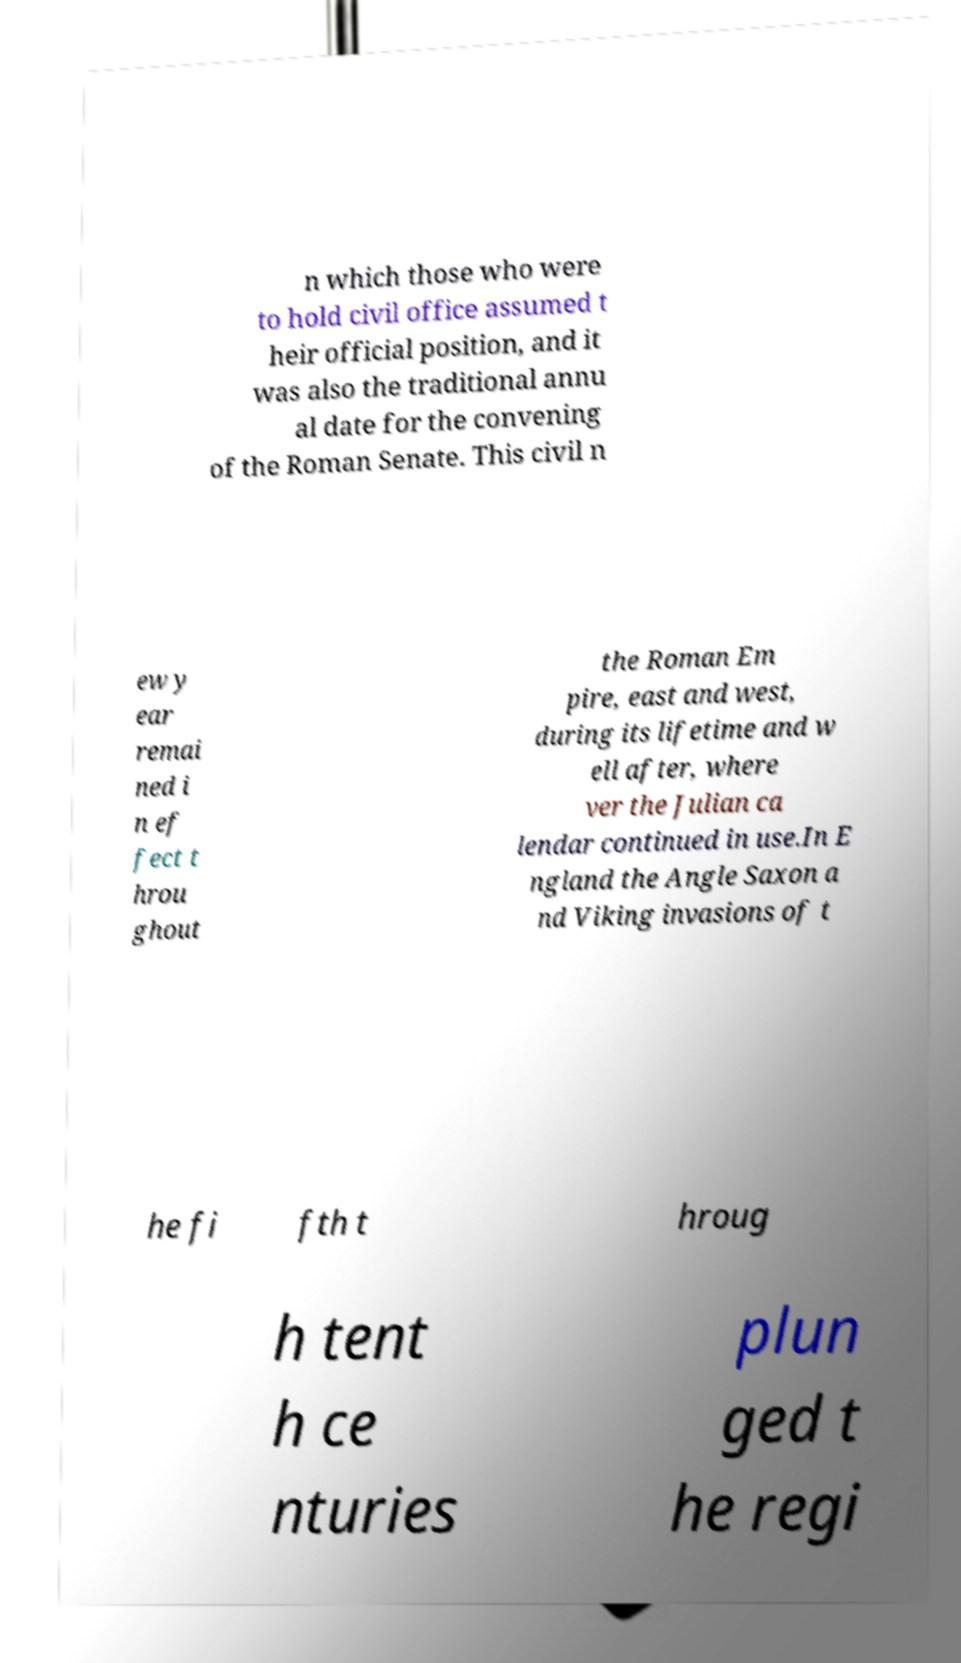Could you extract and type out the text from this image? n which those who were to hold civil office assumed t heir official position, and it was also the traditional annu al date for the convening of the Roman Senate. This civil n ew y ear remai ned i n ef fect t hrou ghout the Roman Em pire, east and west, during its lifetime and w ell after, where ver the Julian ca lendar continued in use.In E ngland the Angle Saxon a nd Viking invasions of t he fi fth t hroug h tent h ce nturies plun ged t he regi 